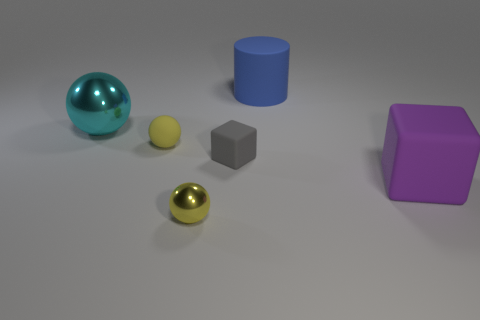Subtract all tiny balls. How many balls are left? 1 Subtract 2 balls. How many balls are left? 1 Subtract all gray blocks. How many blocks are left? 1 Subtract all blocks. How many objects are left? 4 Add 2 large spheres. How many large spheres are left? 3 Add 5 large red blocks. How many large red blocks exist? 5 Add 1 tiny yellow matte objects. How many objects exist? 7 Subtract 0 yellow blocks. How many objects are left? 6 Subtract all cyan cubes. Subtract all blue balls. How many cubes are left? 2 Subtract all blue blocks. How many red cylinders are left? 0 